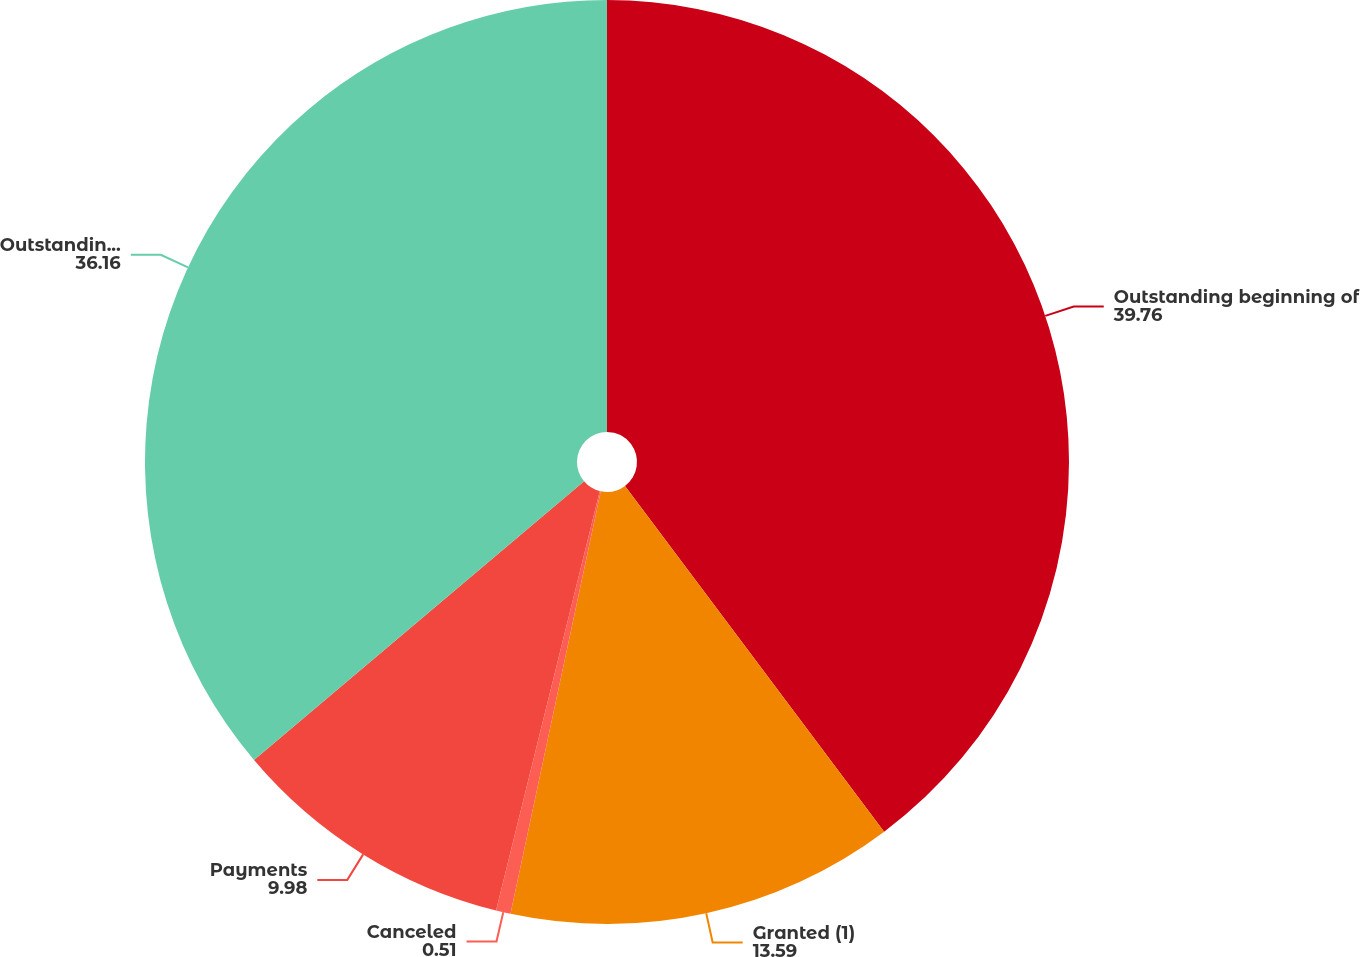Convert chart to OTSL. <chart><loc_0><loc_0><loc_500><loc_500><pie_chart><fcel>Outstanding beginning of<fcel>Granted (1)<fcel>Canceled<fcel>Payments<fcel>Outstanding end of period<nl><fcel>39.76%<fcel>13.59%<fcel>0.51%<fcel>9.98%<fcel>36.16%<nl></chart> 